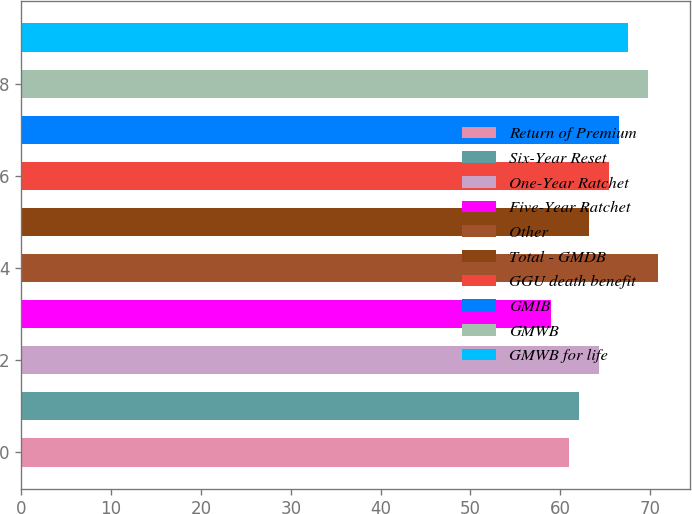Convert chart. <chart><loc_0><loc_0><loc_500><loc_500><bar_chart><fcel>Return of Premium<fcel>Six-Year Reset<fcel>One-Year Ratchet<fcel>Five-Year Ratchet<fcel>Other<fcel>Total - GMDB<fcel>GGU death benefit<fcel>GMIB<fcel>GMWB<fcel>GMWB for life<nl><fcel>61<fcel>62.1<fcel>64.3<fcel>59<fcel>70.9<fcel>63.2<fcel>65.4<fcel>66.5<fcel>69.8<fcel>67.6<nl></chart> 